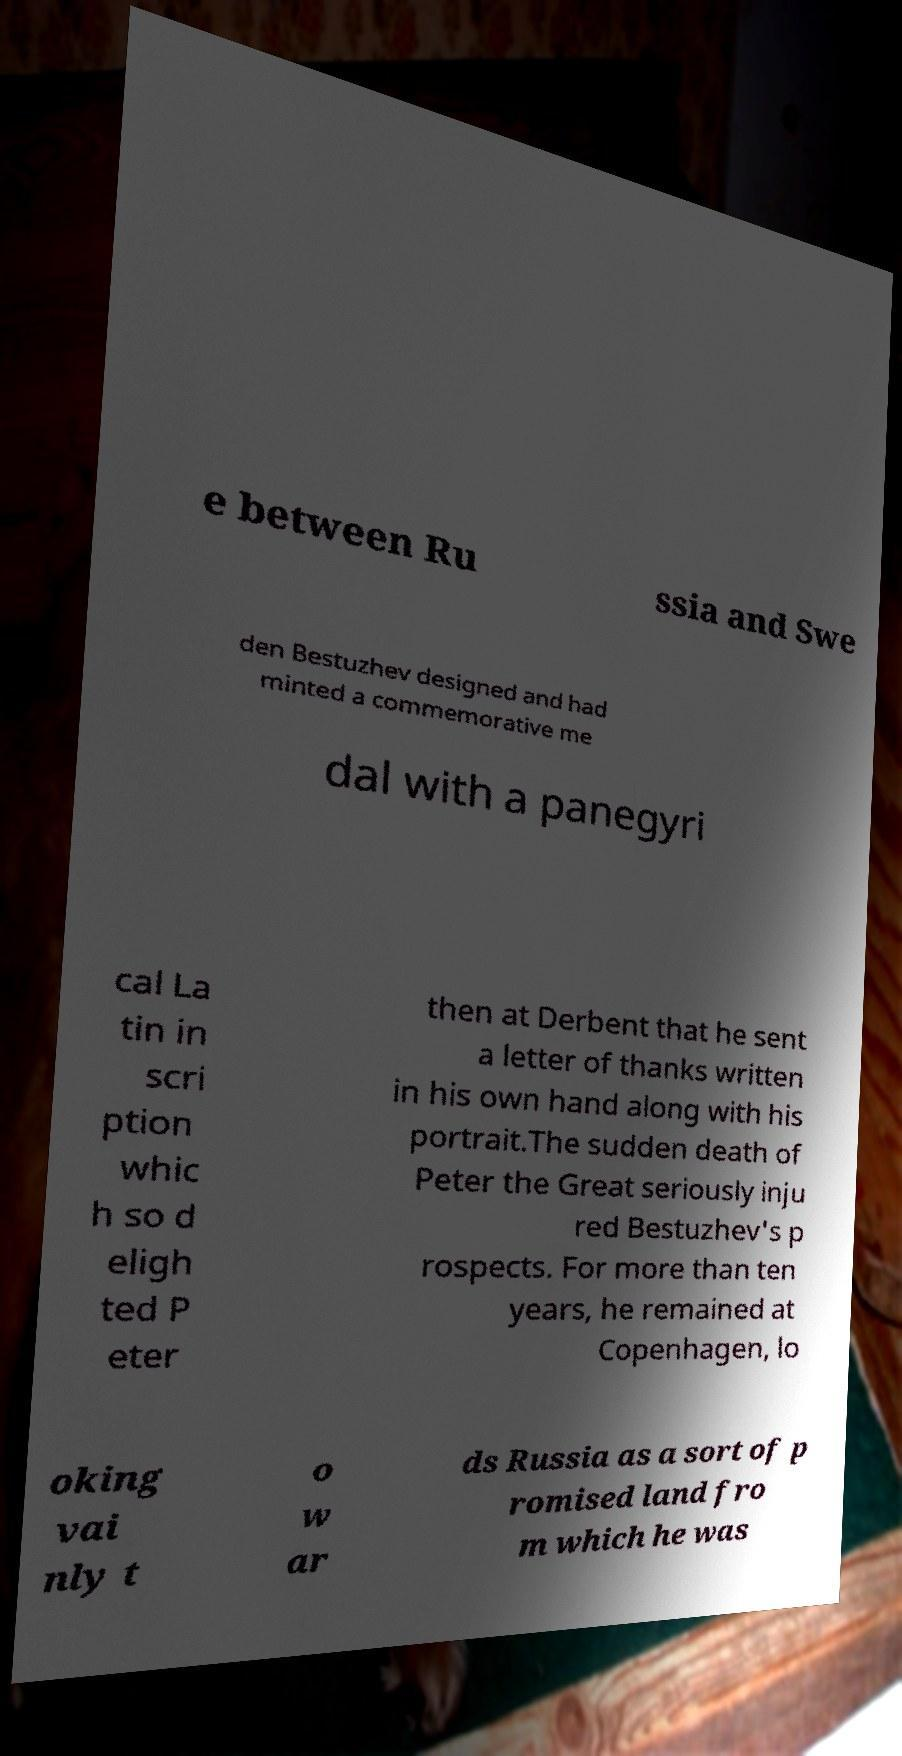Please identify and transcribe the text found in this image. e between Ru ssia and Swe den Bestuzhev designed and had minted a commemorative me dal with a panegyri cal La tin in scri ption whic h so d eligh ted P eter then at Derbent that he sent a letter of thanks written in his own hand along with his portrait.The sudden death of Peter the Great seriously inju red Bestuzhev's p rospects. For more than ten years, he remained at Copenhagen, lo oking vai nly t o w ar ds Russia as a sort of p romised land fro m which he was 